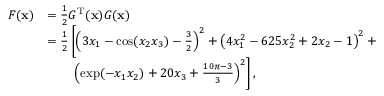Convert formula to latex. <formula><loc_0><loc_0><loc_500><loc_500>{ \begin{array} { r l } { F ( x ) } & { = { \frac { 1 } { 2 } } G ^ { T } ( x ) G ( x ) } \\ & { = { \frac { 1 } { 2 } } \left [ \left ( 3 x _ { 1 } - \cos ( x _ { 2 } x _ { 3 } ) - { \frac { 3 } { 2 } } \right ) ^ { 2 } + \left ( 4 x _ { 1 } ^ { 2 } - 6 2 5 x _ { 2 } ^ { 2 } + 2 x _ { 2 } - 1 \right ) ^ { 2 } + } \\ & { \quad \left ( \exp ( - x _ { 1 } x _ { 2 } ) + 2 0 x _ { 3 } + { \frac { 1 0 \pi - 3 } { 3 } } \right ) ^ { 2 } \right ] , } \end{array} }</formula> 